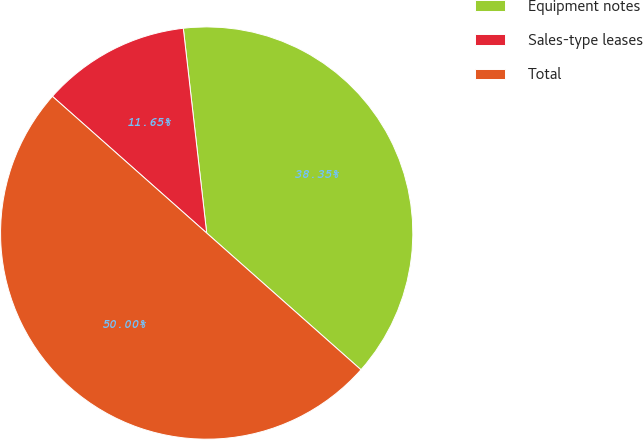<chart> <loc_0><loc_0><loc_500><loc_500><pie_chart><fcel>Equipment notes<fcel>Sales-type leases<fcel>Total<nl><fcel>38.35%<fcel>11.65%<fcel>50.0%<nl></chart> 